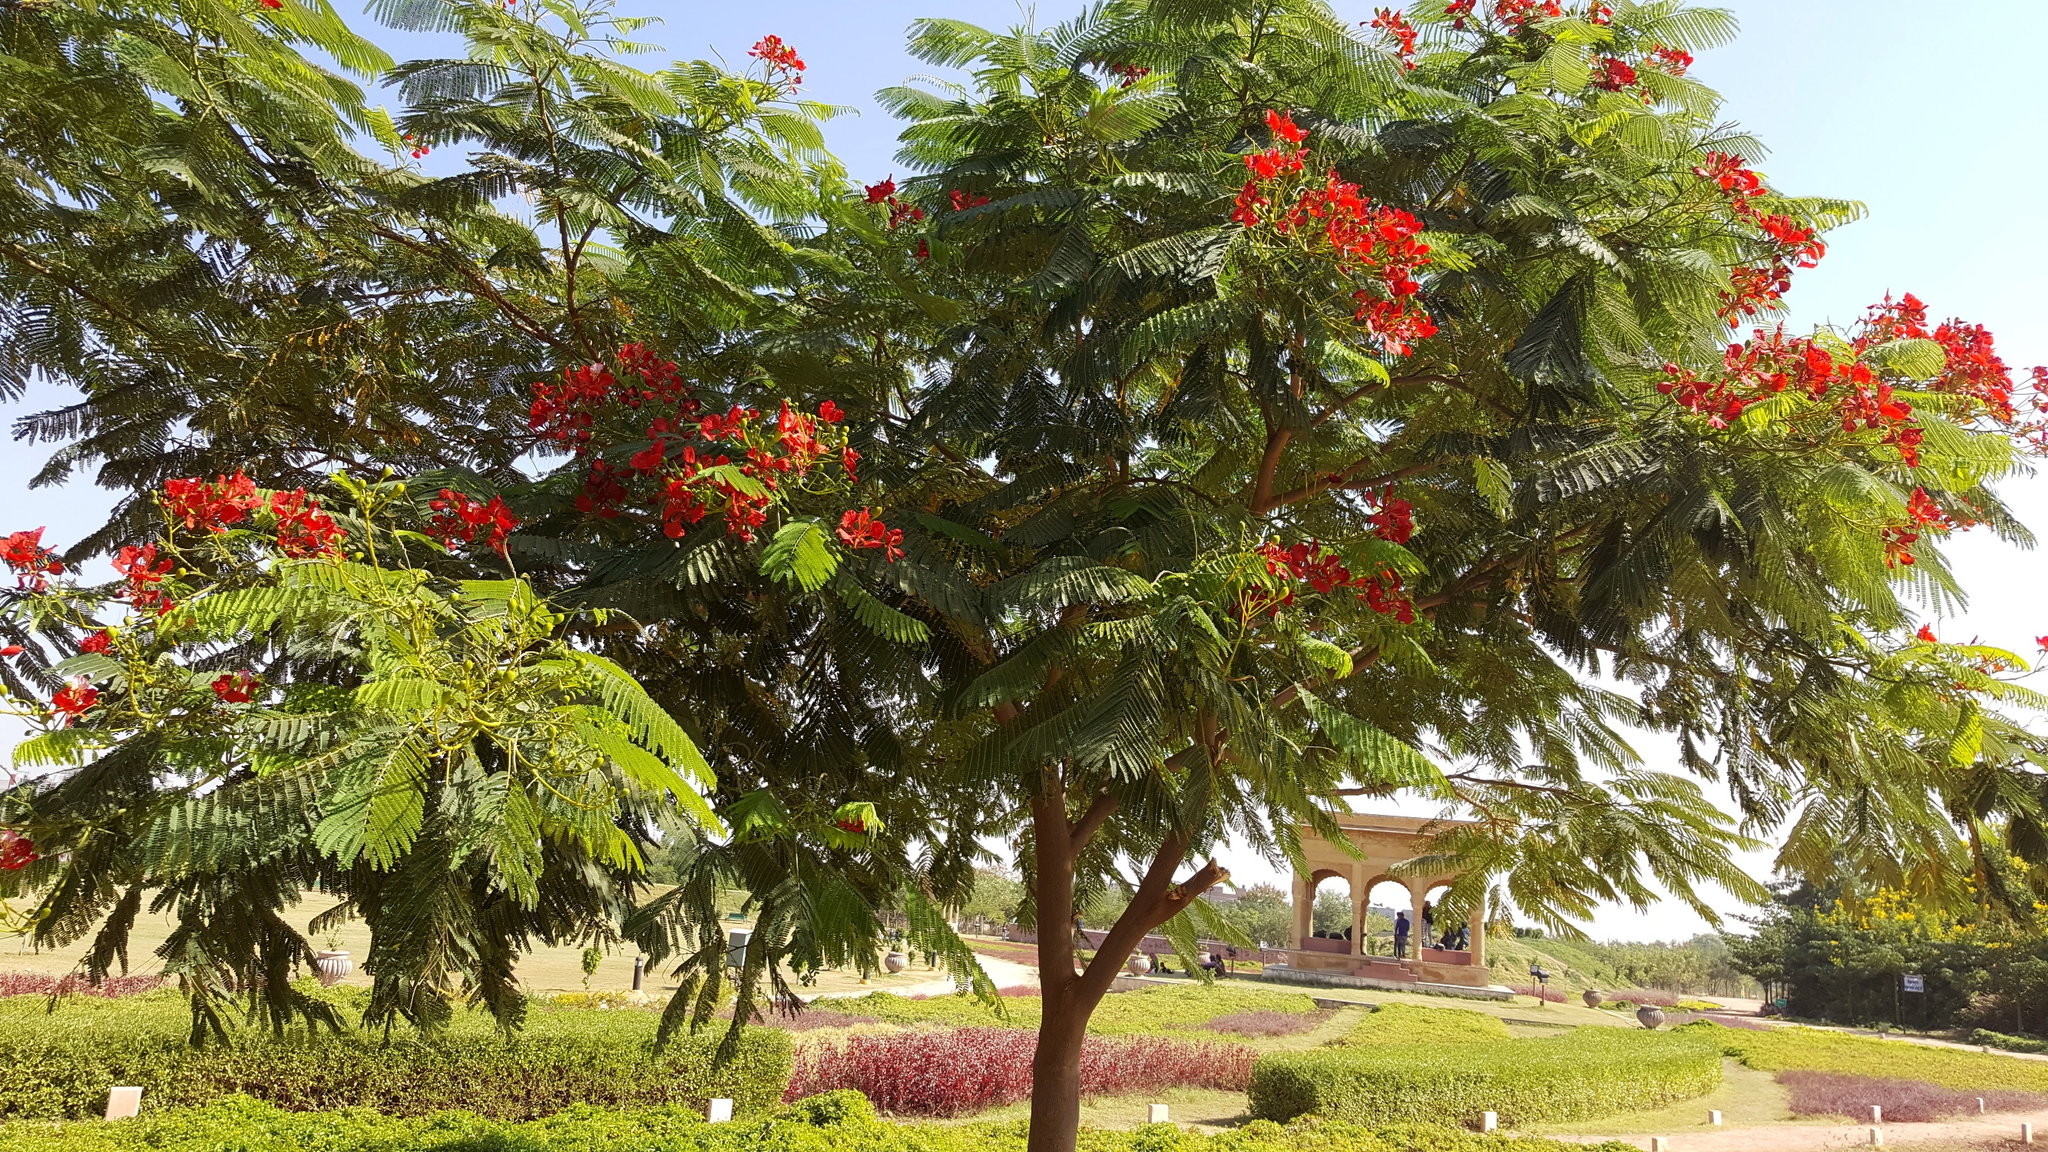What are the key elements in this picture? The key elements in this captivating image include a lush, verdant tree prominently adorned with striking red flowers, likely a variety of Delonix regia, commonly known as the Royal Poinciana or Flamboyant. The tree's broad, feathery green leaves complement its vivid blossoms, making it the focal point of the scene. Surrounding the tree is a well-maintained park, suggesting a tranquil and inviting space for relaxation or leisure walks.

The background features a classical gazebo, which adds an architectural interest and provides a shaded area for park visitors. The gazebo's style, featuring open sides and a raised platform, is typical of structures designed for outdoor concerts or as a quiet retreat from the sun. A clear blue sky and sunlit conditions convey a warm, pleasant day, ideal for outdoor activities. The composition of the image, with its vibrant natural and built elements, invites viewers to appreciate both the beauty of the natural environment and human ingenuity. 